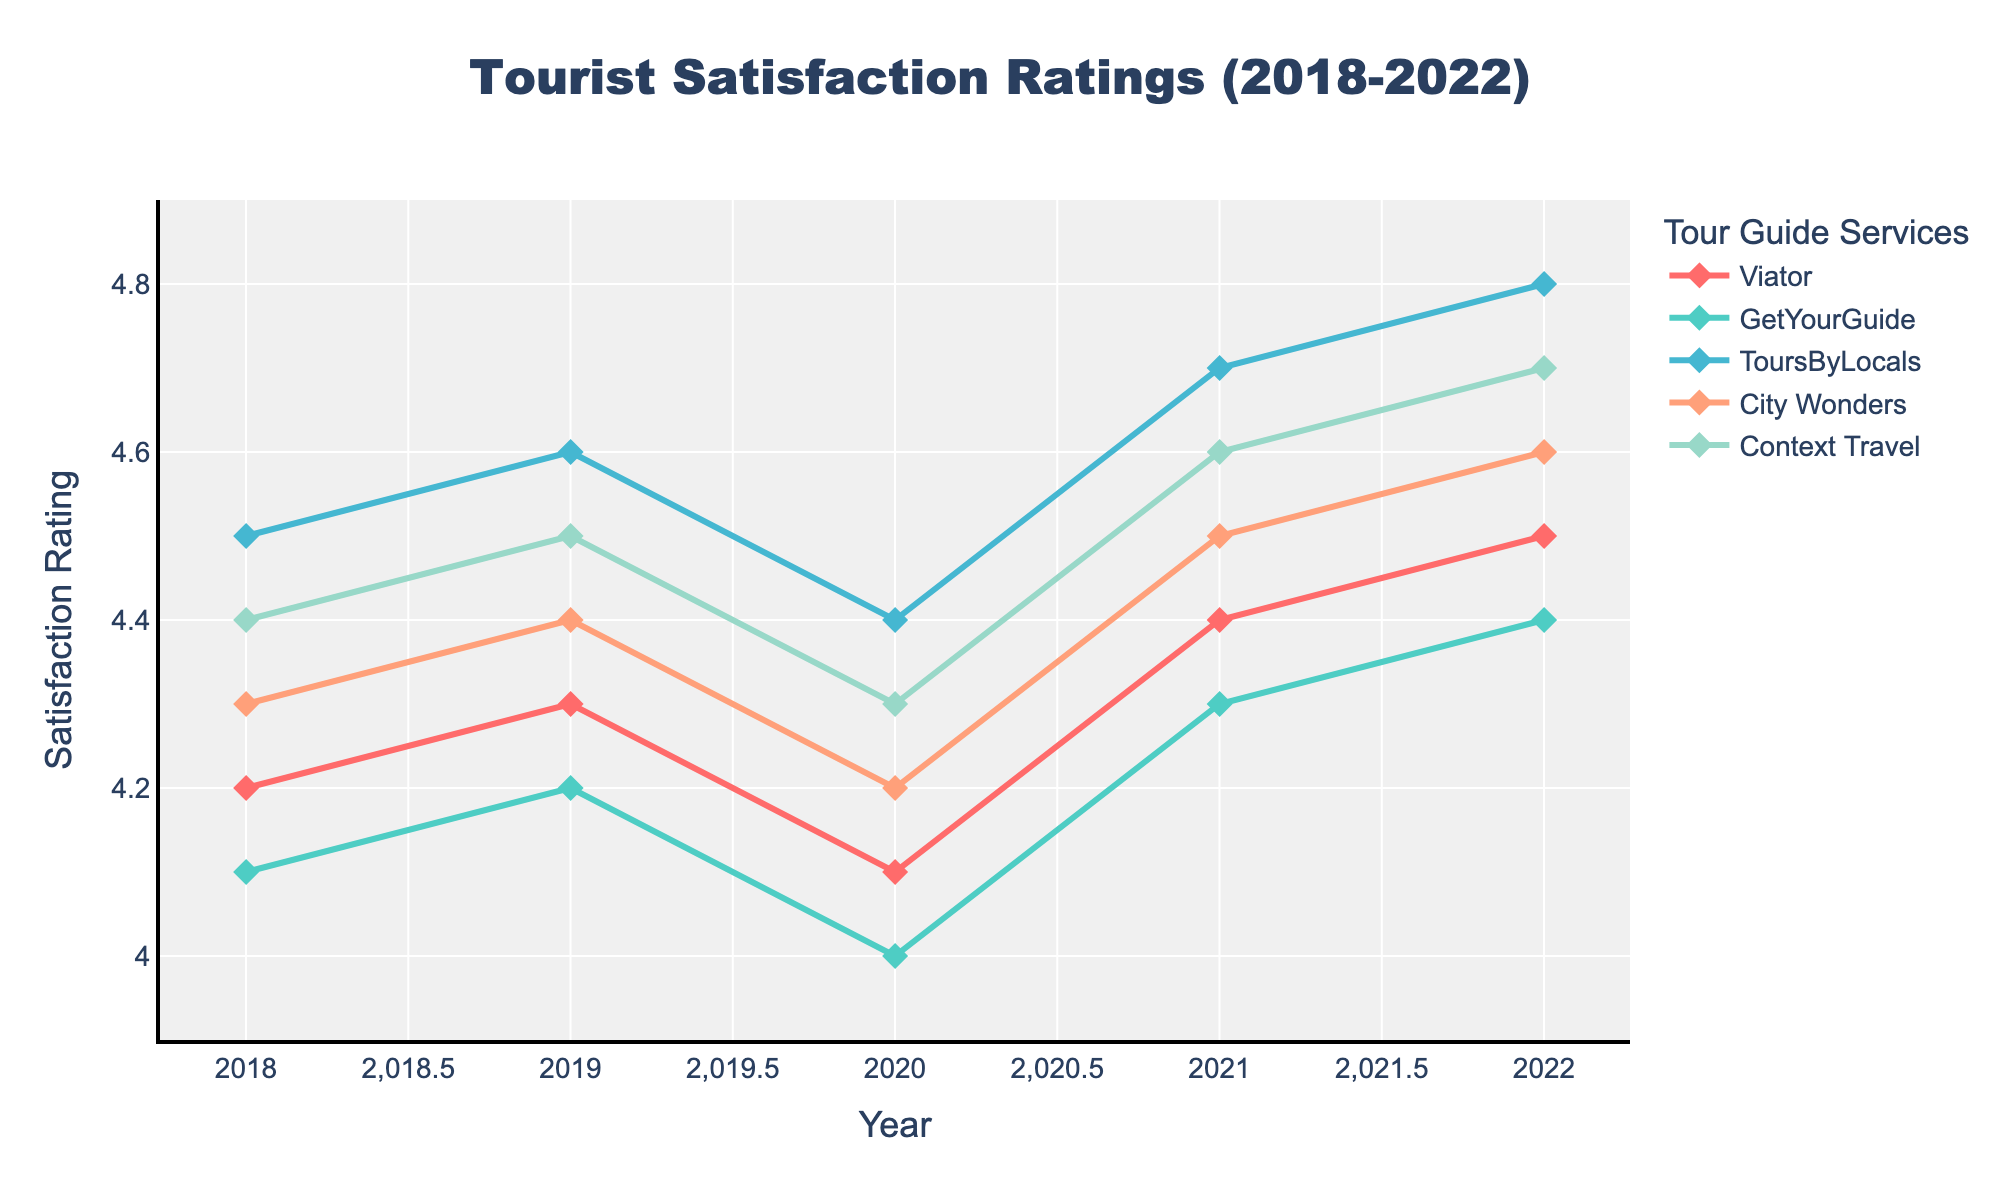Which tour guide service had the highest satisfaction rating in 2022? Look at the endpoints of the lines in 2022; the highest point corresponds to ToursByLocals.
Answer: ToursByLocals Between which two consecutive years did Viator see a decrease in satisfaction rating? Observe the line for Viator; it dips between 2019 and 2020.
Answer: 2019 and 2020 What was the average satisfaction rating of City Wonders over the 5-year period? Add up all five satisfaction ratings for City Wonders (4.3 + 4.4 + 4.2 + 4.5 + 4.6) and divide by 5. The sum is 22.0, so the average is 22.0 / 5 = 4.4.
Answer: 4.4 Which tour guide service consistently improved its satisfaction rating from 2018 to 2022? Look for the line that moves upwards continuously from 2018 to 2022; this is ToursByLocals.
Answer: ToursByLocals Did Context Travel ever have the highest rating in any given year? Compare the endpoints of the lines for each year from 2018 to 2022; Context Travel was never the highest among all.
Answer: No How did GetYourGuide's satisfaction rating change from 2020 to 2021? Observe the line for GetYourGuide; it increases from 4.0 in 2020 to 4.3 in 2021.
Answer: Increased Which year had the lowest satisfaction rating for any tour guide service, and what was the value? Identify the lowest point across all lines; GetYourGuide had the lowest rating of 4.0 in 2020.
Answer: 2020, 4.0 How much did the satisfaction rating for Context Travel increase from 2020 to 2022? Subtract Context Travel's rating in 2020 from its rating in 2022 (4.7 - 4.3 = 0.4).
Answer: 0.4 Compare the ratings of Viator and City Wonders in 2019. Which one had a higher rating and by how much? Viator had a rating of 4.3 and City Wonders had 4.4 in 2019. The difference is 4.4 - 4.3 = 0.1. City Wonders had a higher rating by 0.1.
Answer: City Wonders, 0.1 Among all the services, which one saw the biggest improvement in satisfaction rating from 2018 to 2022? Calculate the difference between 2018 and 2022 ratings for each service. ToursByLocals improved by 0.3 (4.8-4.5); GetYourGuide improved by 0.3 (4.4-4.1); Viator improved by 0.3 (4.5-4.2); City Wonders improved by 0.3 (4.6-4.3); Context Travel improved by 0.3 (4.7-4.4). They all improved equally by 0.3.
Answer: Tie by 0.3 